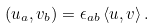<formula> <loc_0><loc_0><loc_500><loc_500>\left ( u _ { a } , v _ { b } \right ) = \epsilon _ { a b } \left < u , v \right > .</formula> 